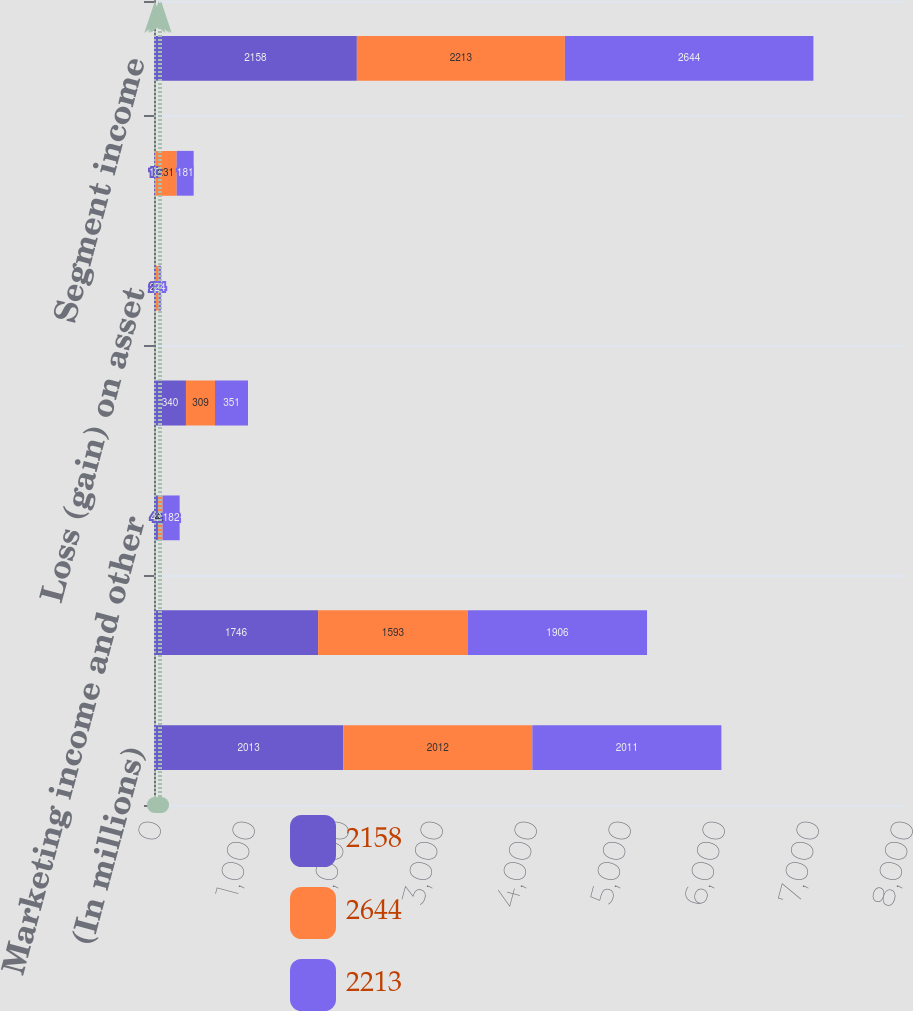Convert chart. <chart><loc_0><loc_0><loc_500><loc_500><stacked_bar_chart><ecel><fcel>(In millions)<fcel>Results of continuing<fcel>Marketing income and other<fcel>Income from equity method<fcel>Loss (gain) on asset<fcel>Long-lived asset impairments<fcel>Segment income<nl><fcel>2158<fcel>2013<fcel>1746<fcel>42<fcel>340<fcel>20<fcel>10<fcel>2158<nl><fcel>2644<fcel>2012<fcel>1593<fcel>49<fcel>309<fcel>31<fcel>231<fcel>2213<nl><fcel>2213<fcel>2011<fcel>1906<fcel>182<fcel>351<fcel>24<fcel>181<fcel>2644<nl></chart> 